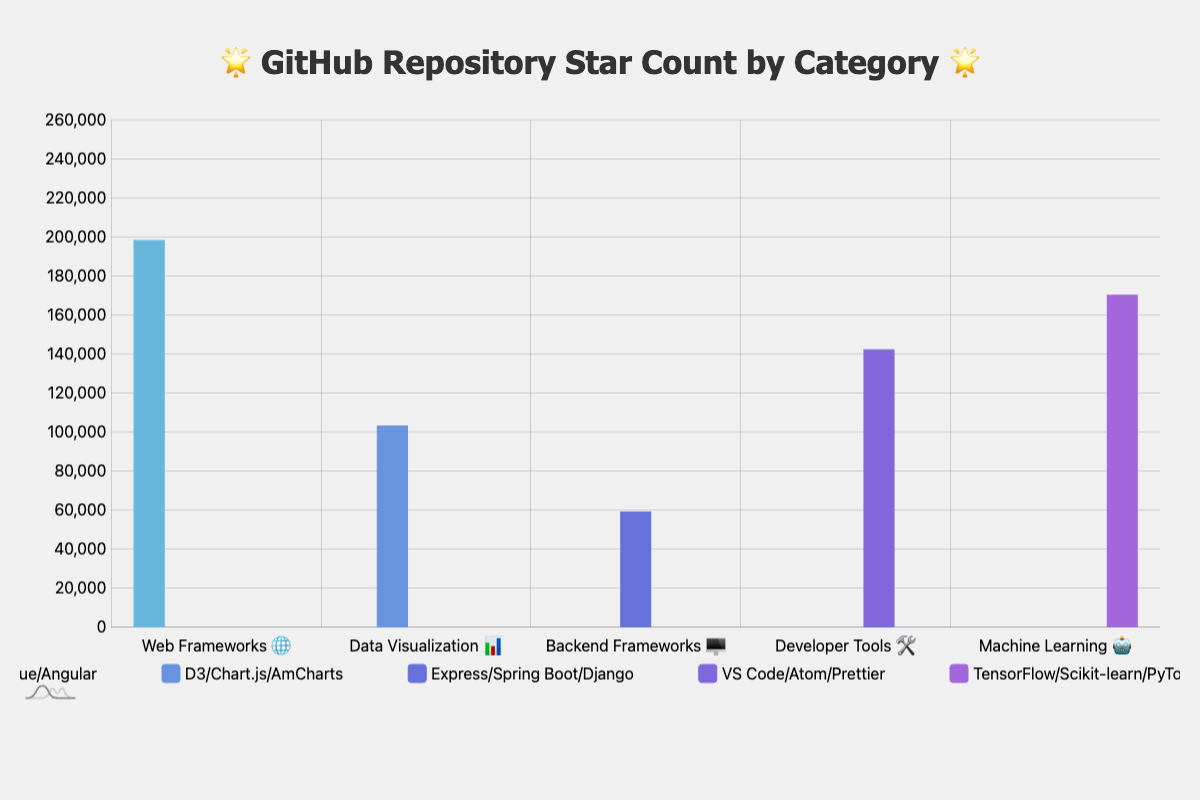Which category has the repository with the highest star count? By observing the bar heights and labels, the "Web Frameworks 🌐" category has the repository "vue" with the highest star count at 201,000.
Answer: Web Frameworks 🌐 How many repositories have more than 100,000 stars? Look for repositories with star counts over 100,000. The repositories are "react" (198,000), "vue" (201,000), "d3" (103,000), "vscode" (142,000), and "tensorflow" (170,000). This makes a total of 5 repositories.
Answer: 5 Compare the total star counts of "Data Visualization 📊" and "Backend Frameworks 🖥️". Which one is greater and by how much? Sum the stars for each category. "Data Visualization 📊" has 103,000 + 60,000 + 3,500 = 166,500 stars. "Backend Frameworks 🖥️" has 59,000 + 66,000 + 68,000 = 193,000 stars. The "Backend Frameworks 🖥️" category has 193,000 - 166,500 = 26,500 more stars.
Answer: Backend Frameworks 🖥️ by 26,500 What is the star count difference between "react" and the least starred repository? "react" has 198,000 stars. The least starred repository, "amcharts," has 3,500 stars. The difference is 198,000 - 3,500 = 194,500 stars.
Answer: 194,500 Which repository in the "Developer Tools 🛠️" category has the fewest stars? By examining the bars in the "Developer Tools 🛠️" category, "prettier" has the fewest stars with 44,000.
Answer: prettier In the "Machine Learning 🤖" category, what is the average star count across all repositories? Add the star counts of "tensorflow" (170,000), "scikit-learn" (53,000), and "pytorch" (64,000). The total is 170,000 + 53,000 + 64,000 = 287,000. Divide by 3 to get the average: 287,000 / 3 ≈ 95,667.
Answer: 95,667 Which category has the widest range of star counts? Calculate the range for each category by subtracting the smallest star count from the largest. "Web Frameworks 🌐" ranges from 201,000 to 86,000; "Data Visualization 📊" from 103,000 to 3,500; "Backend Frameworks 🖥️" from 68,000 to 59,000; "Developer Tools 🛠️" from 142,000 to 44,000; "Machine Learning 🤖" from 170,000 to 53,000. The widest range is in the "Web Frameworks 🌐" category with a range of 201,000 - 86,000 = 115,000.
Answer: Web Frameworks 🌐, 115,000 Which category has the highest cumulative star count? Sum the stars for each category: "Web Frameworks 🌐" (485,000), "Data Visualization 📊" (166,500), "Backend Frameworks 🖥️" (193,000), "Developer Tools 🛠️" (244,000), and "Machine Learning 🤖" (287,000). The "Machine Learning 🤖" category has the highest cumulative star count with 287,000.
Answer: Machine Learning 🤖 